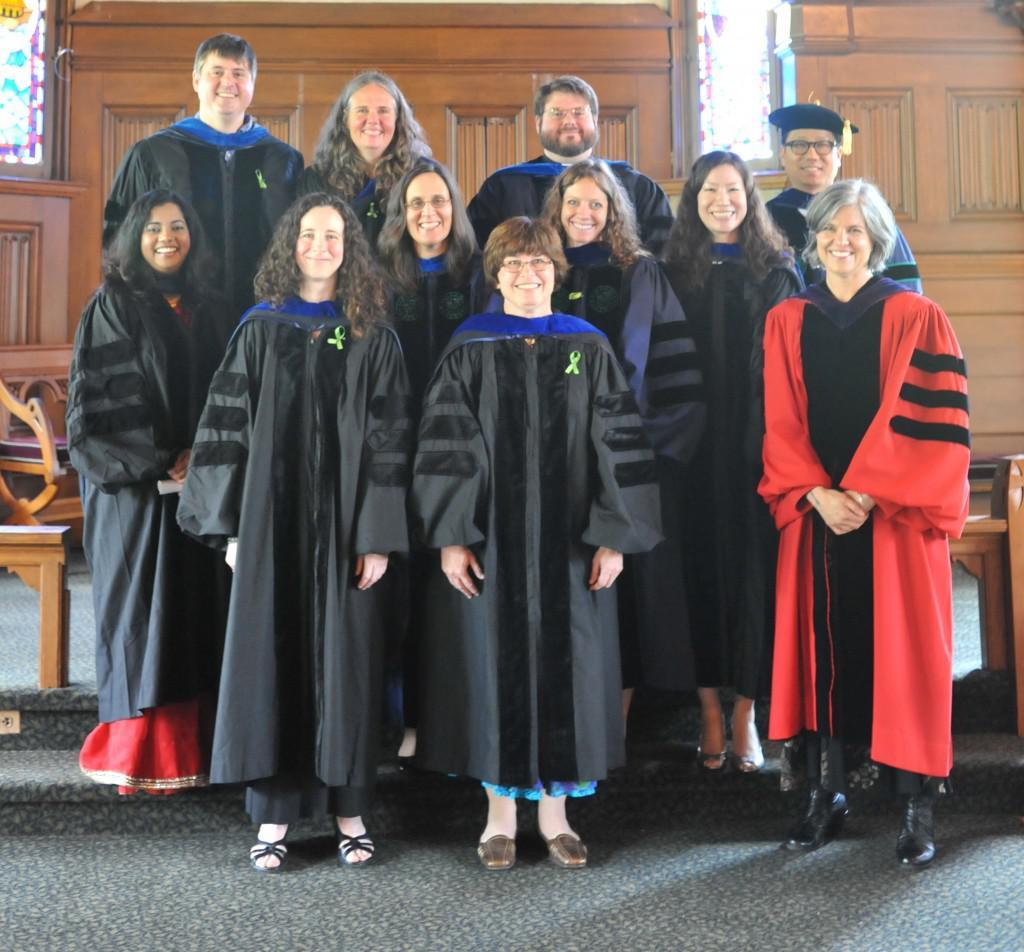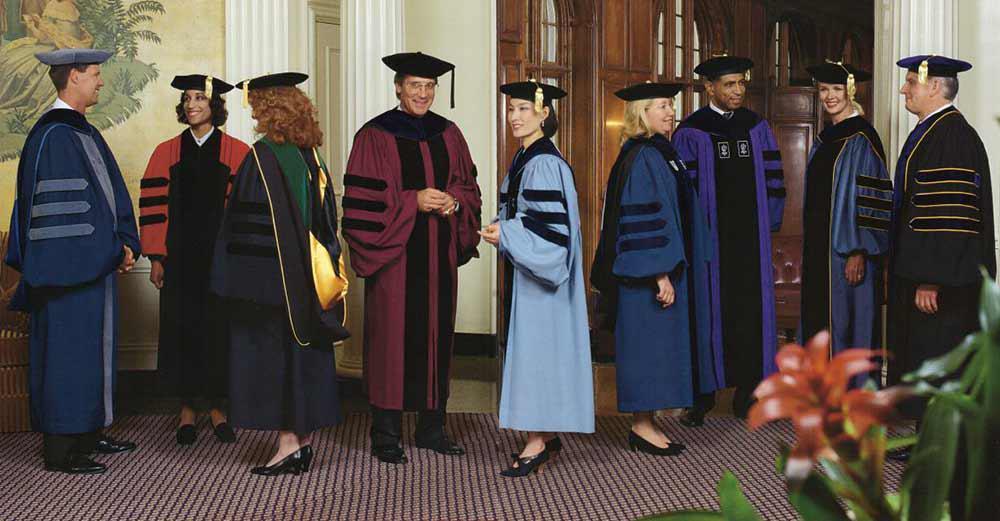The first image is the image on the left, the second image is the image on the right. Assess this claim about the two images: "At least one person is holding a piece of paper.". Correct or not? Answer yes or no. No. 